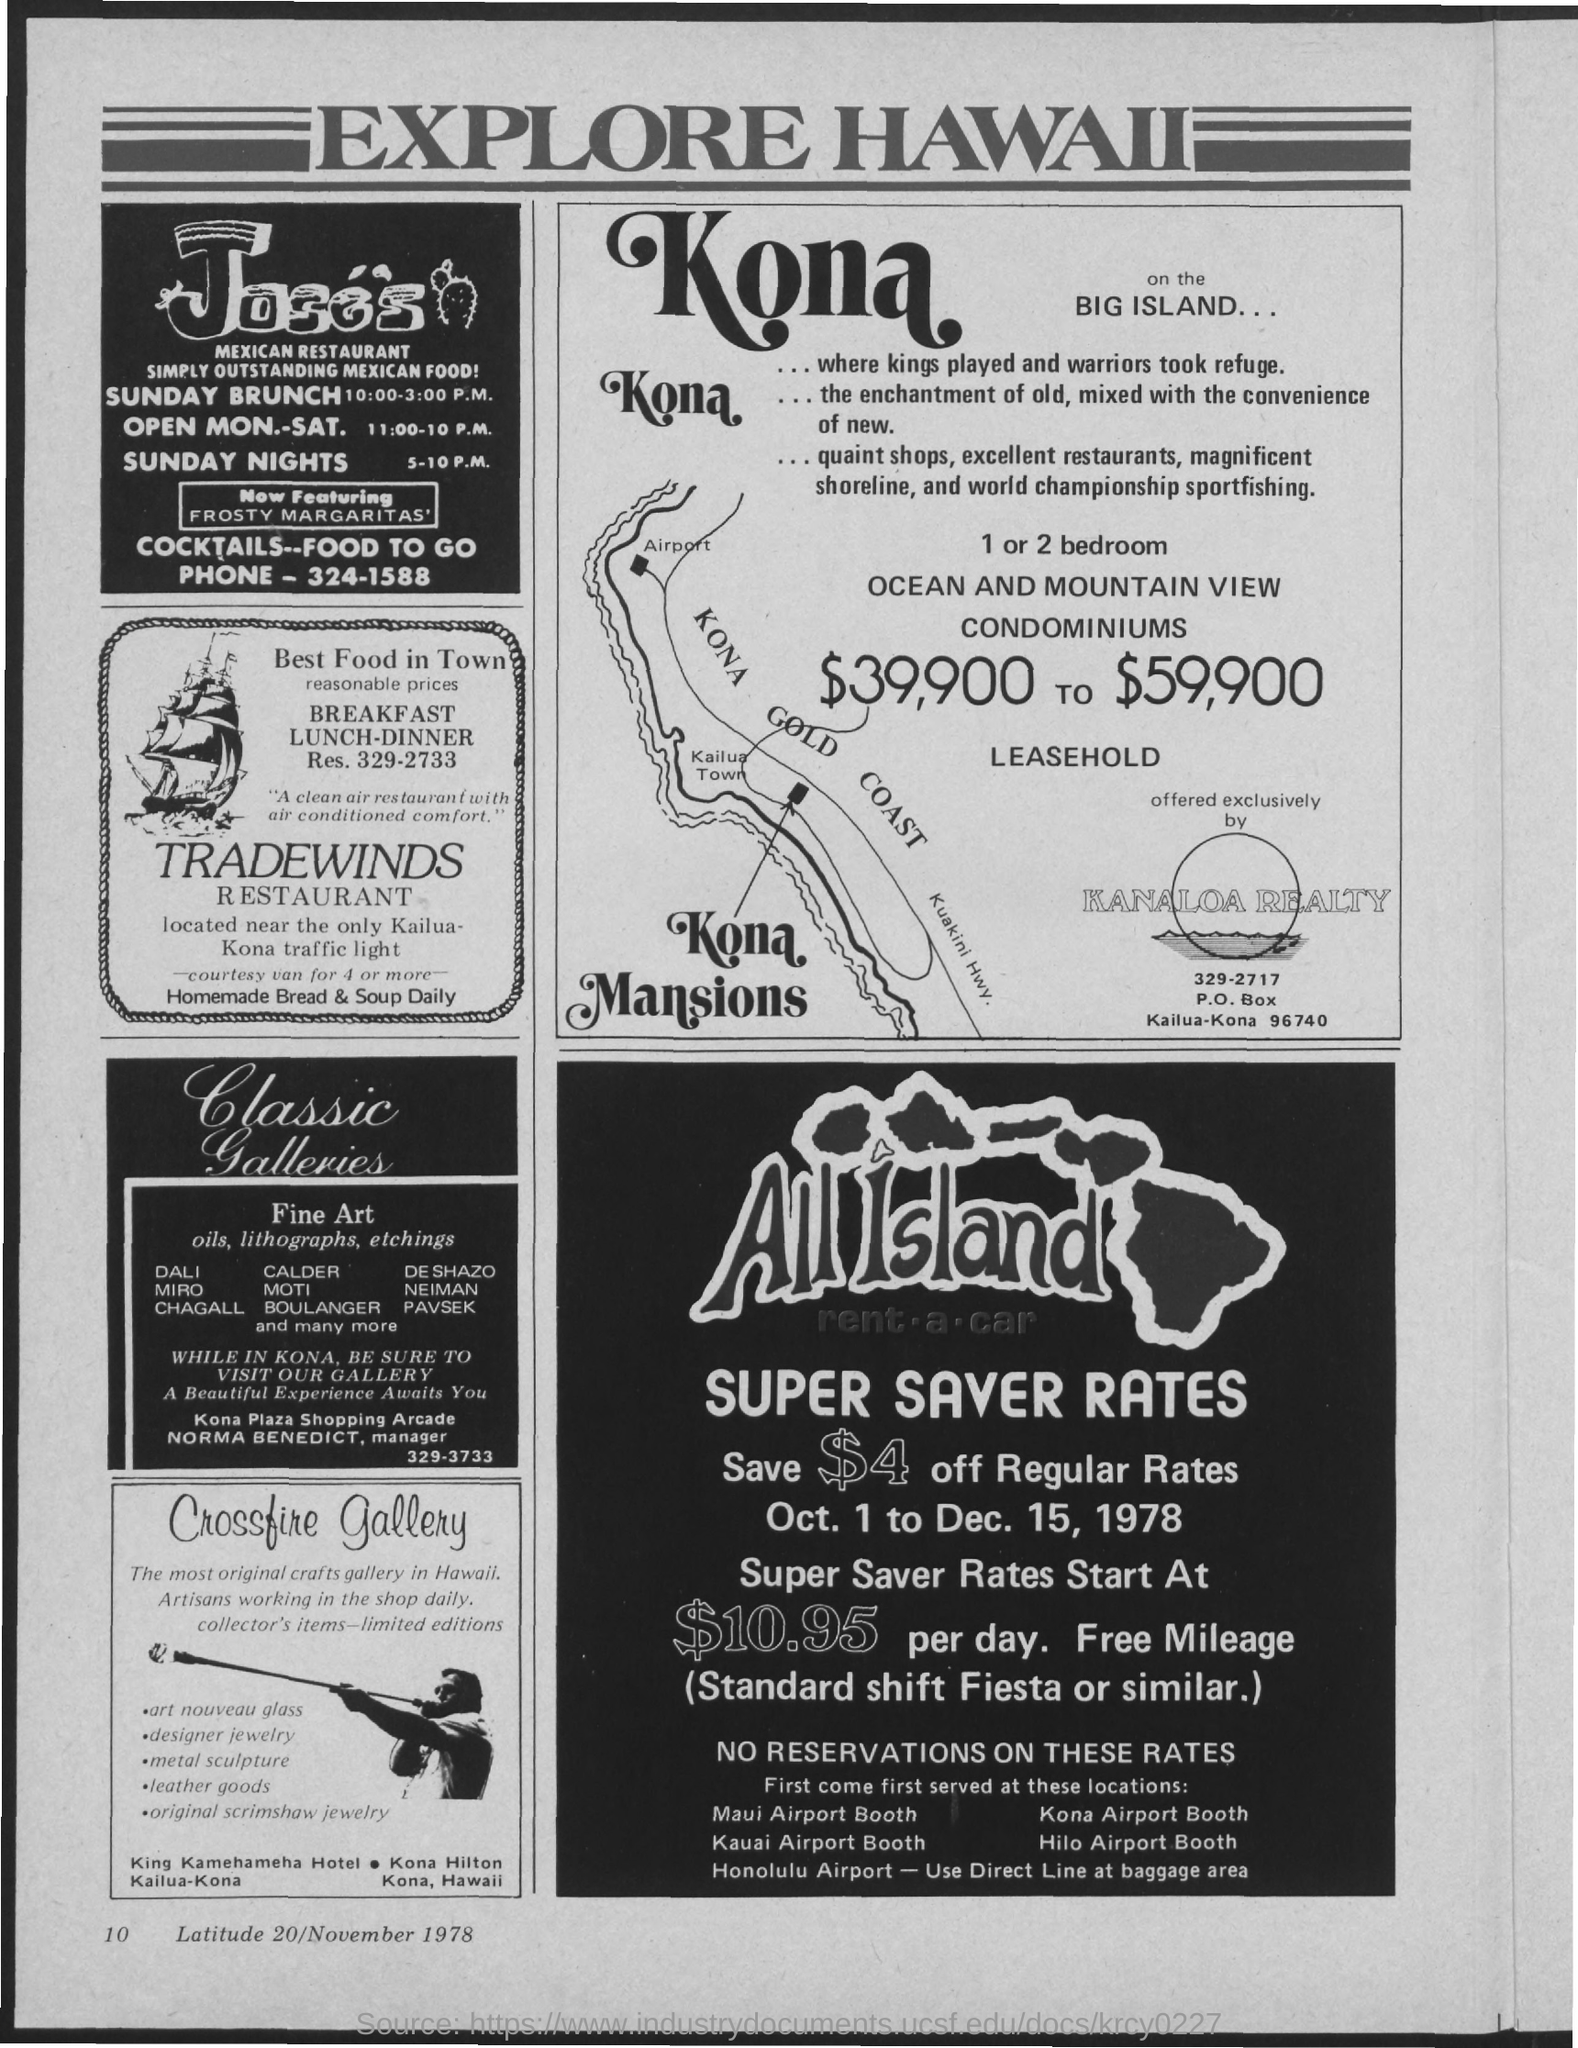Outline some significant characteristics in this image. The document in which advertisements for "EXPLORE HAWAII" are given is called a brochure. The Super Saver Rates for the All Island daily rate is $10.95. Please provide the month and year from the following information: 'Crossfire Gallery', November 1978. The "Super Saver Rates" for "All Island" applied from October 1st to December 15th, 1978. Provide the "Latitude" number given below "Crossfire Gallery"?" is a question that asks for a specific piece of information. 